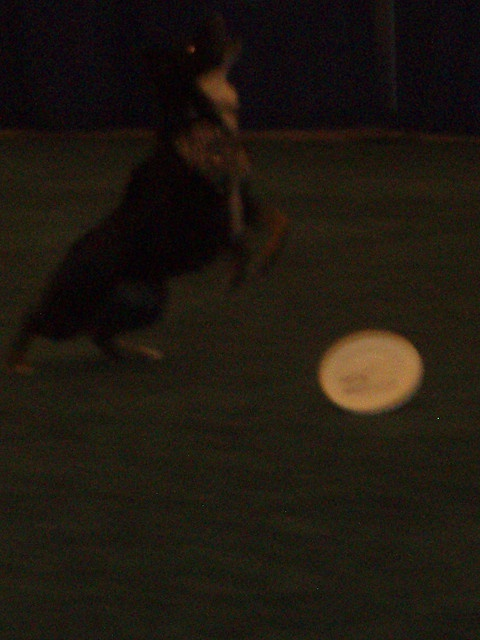Describe the objects in this image and their specific colors. I can see dog in black, maroon, and brown tones and frisbee in black, olive, and maroon tones in this image. 